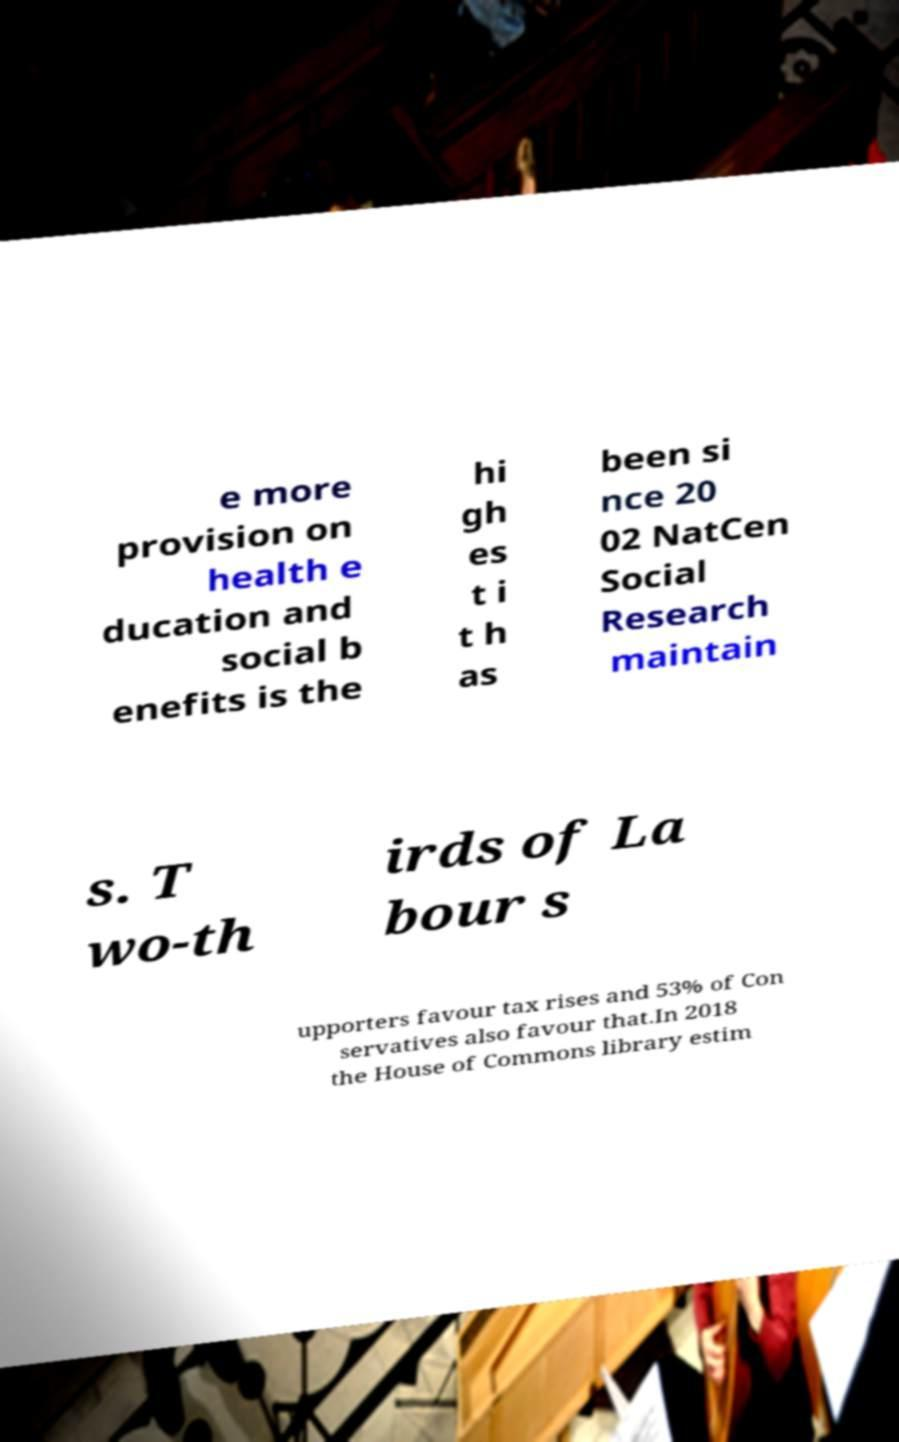What messages or text are displayed in this image? I need them in a readable, typed format. e more provision on health e ducation and social b enefits is the hi gh es t i t h as been si nce 20 02 NatCen Social Research maintain s. T wo-th irds of La bour s upporters favour tax rises and 53% of Con servatives also favour that.In 2018 the House of Commons library estim 